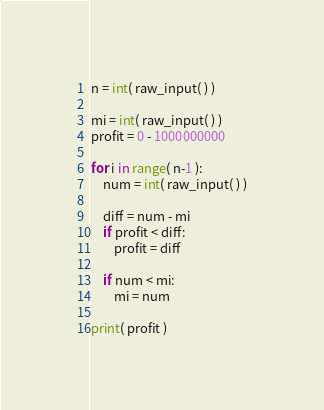Convert code to text. <code><loc_0><loc_0><loc_500><loc_500><_Python_>n = int( raw_input( ) )

mi = int( raw_input( ) )
profit = 0 - 1000000000

for i in range( n-1 ):
	num = int( raw_input( ) )
	
	diff = num - mi
	if profit < diff:
		profit = diff

	if num < mi:
		mi = num

print( profit )</code> 